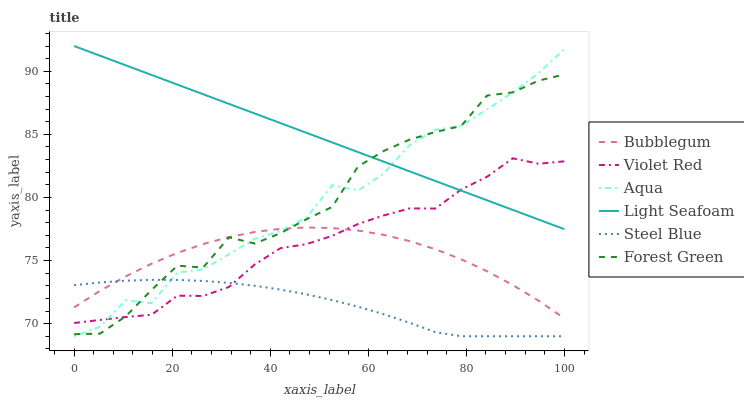Does Steel Blue have the minimum area under the curve?
Answer yes or no. Yes. Does Light Seafoam have the maximum area under the curve?
Answer yes or no. Yes. Does Aqua have the minimum area under the curve?
Answer yes or no. No. Does Aqua have the maximum area under the curve?
Answer yes or no. No. Is Light Seafoam the smoothest?
Answer yes or no. Yes. Is Forest Green the roughest?
Answer yes or no. Yes. Is Aqua the smoothest?
Answer yes or no. No. Is Aqua the roughest?
Answer yes or no. No. Does Aqua have the lowest value?
Answer yes or no. Yes. Does Bubblegum have the lowest value?
Answer yes or no. No. Does Light Seafoam have the highest value?
Answer yes or no. Yes. Does Aqua have the highest value?
Answer yes or no. No. Is Steel Blue less than Light Seafoam?
Answer yes or no. Yes. Is Light Seafoam greater than Bubblegum?
Answer yes or no. Yes. Does Aqua intersect Bubblegum?
Answer yes or no. Yes. Is Aqua less than Bubblegum?
Answer yes or no. No. Is Aqua greater than Bubblegum?
Answer yes or no. No. Does Steel Blue intersect Light Seafoam?
Answer yes or no. No. 